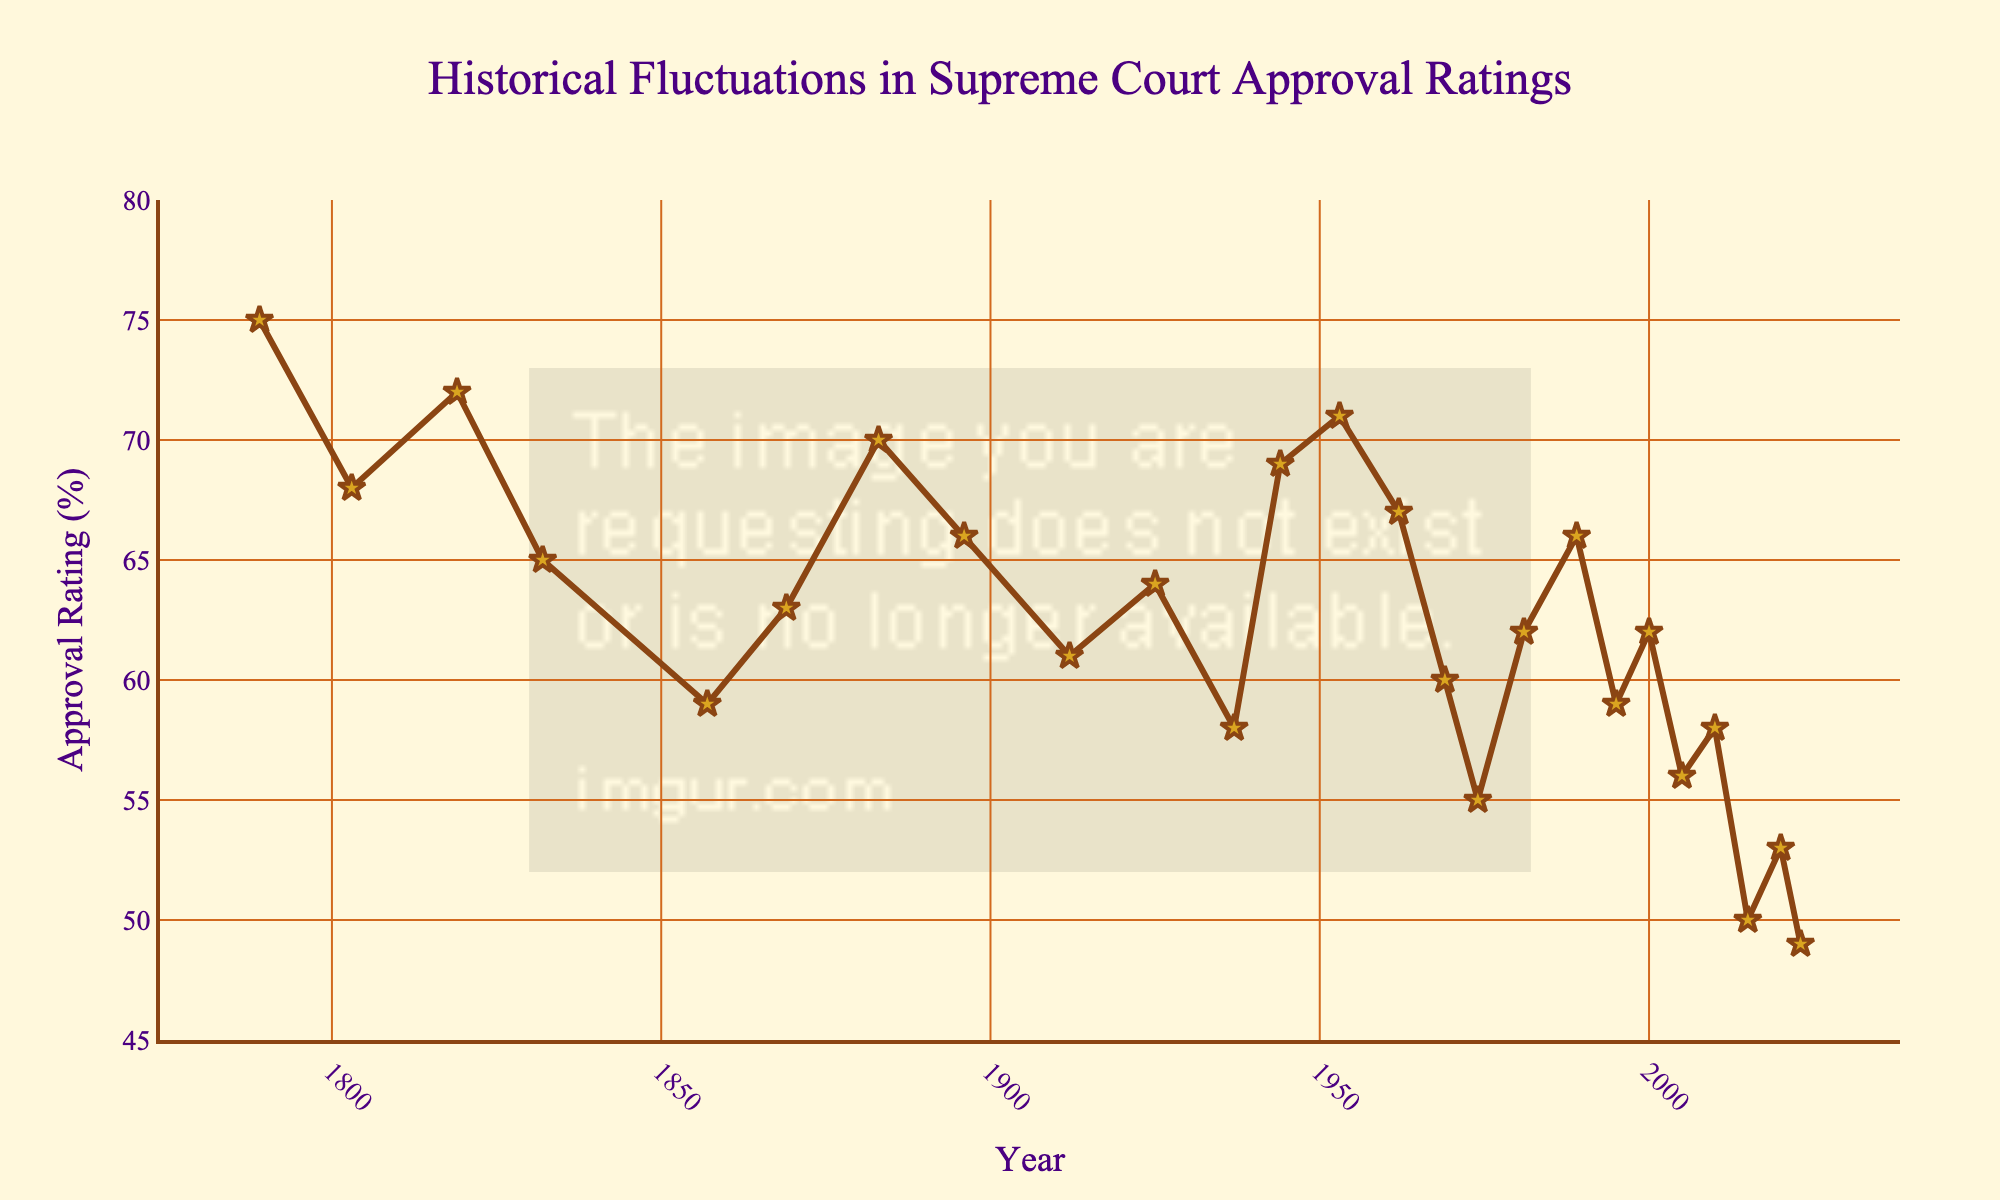What was the approval rating in 1857? First, locate the year 1857 along the horizontal axis; then, trace vertically up to the plotted line. The approval rating at this point is marked as 59.
Answer: 59 How many times did the approval rating drop below 60? To determine this, identify all years where the approval rating points are below the horizontal line marking 60. These years are 1857, 1937, 1969, 1974, 1995, 2005, 2010, 2015, 2020, and 2023, totaling 10.
Answer: 10 Which year experienced the lowest approval rating and what was it? Find the lowest point on the chart, which is in 2023, with the approval rating at 49.
Answer: 49 What is the difference in approval ratings between 1789 and 2023? The approval rating in 1789 is 75 and in 2023 it is 49. Subtract 49 from 75 to get the difference, which is 26.
Answer: 26 During which decade did the approval rating rise the most dramatically? Compare the changes in approval rating from the start to the end of each decade. The notable rise happens between 1944 (69) and 1953 (71).
Answer: 1950s Was there any decade where the approval rating remained relatively stable? Check each decade for significant changes. The 1880s appear stable with ratings of 70 in 1883 to 66 in 1896.
Answer: 1880s Can you identify a period when the approval rating was consistently above 70? If so, which years? Look through the chart for a period with consecutive years above 70. This period is not present in the data. Each year must be considered individually.
Answer: None What is the mean approval rating of the Supreme Court from 1789 to 2023? Sum the approval ratings: 75 + 68 + 72 + 65 + 59 + 63 + 70 + 66 + 61 + 64 + 58 + 69 + 71 + 67 + 60 + 55 + 62 + 66 + 59 + 62 + 56 + 58 + 50 + 53 + 49 = 1443. Divide by the number of years (25) to get 1443/25 = 57.72.
Answer: 57.72 What were the approval ratings in 1981 and 1989, and how did they compare? Locate the points for 1981 (62) and 1989 (66) and compare them. The approval rating increased by 4 points.
Answer: In 1981: 62, In 1989: 66, Increase: 4 How does the approval rating in 1937 compare to that in 2023? Compare the points for the two years. In 1937, the rating was 58, and in 2023, it was 49, indicating a decrease.
Answer: 1937: 58, 2023: 49, Decrease: 9 